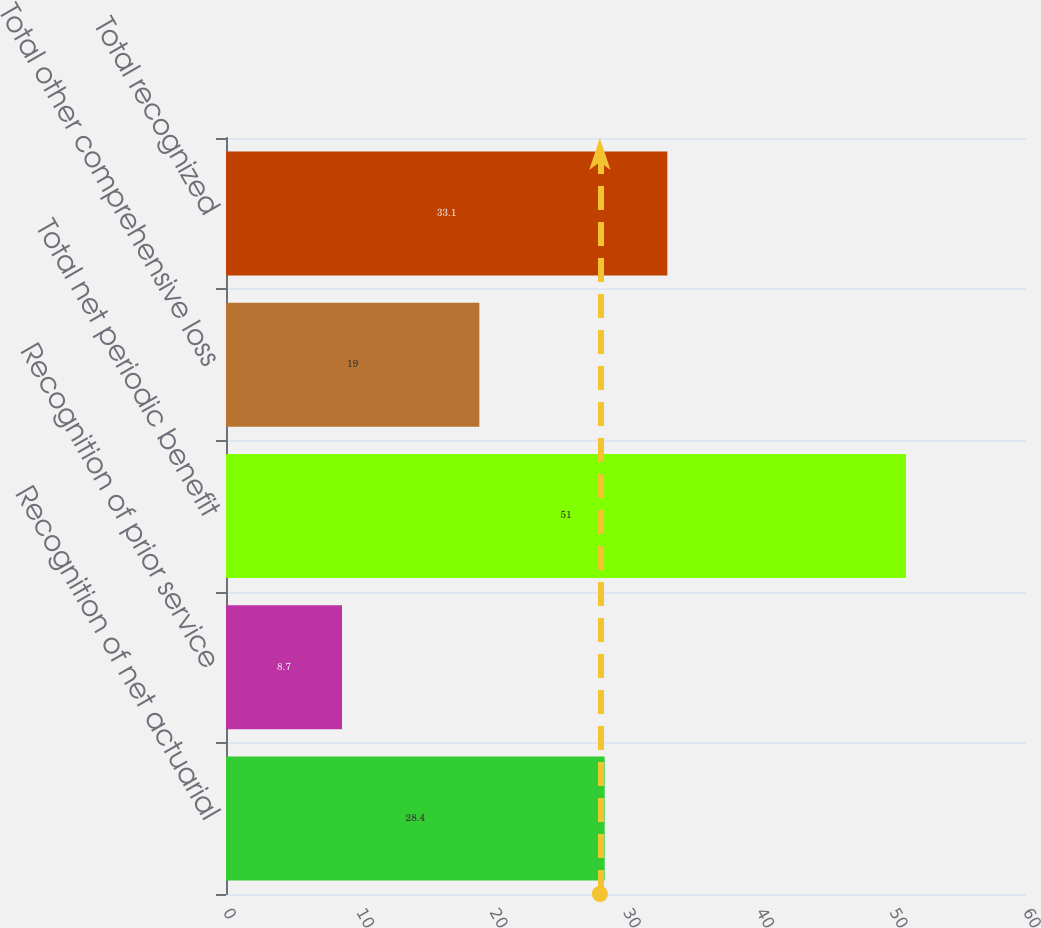Convert chart. <chart><loc_0><loc_0><loc_500><loc_500><bar_chart><fcel>Recognition of net actuarial<fcel>Recognition of prior service<fcel>Total net periodic benefit<fcel>Total other comprehensive loss<fcel>Total recognized<nl><fcel>28.4<fcel>8.7<fcel>51<fcel>19<fcel>33.1<nl></chart> 